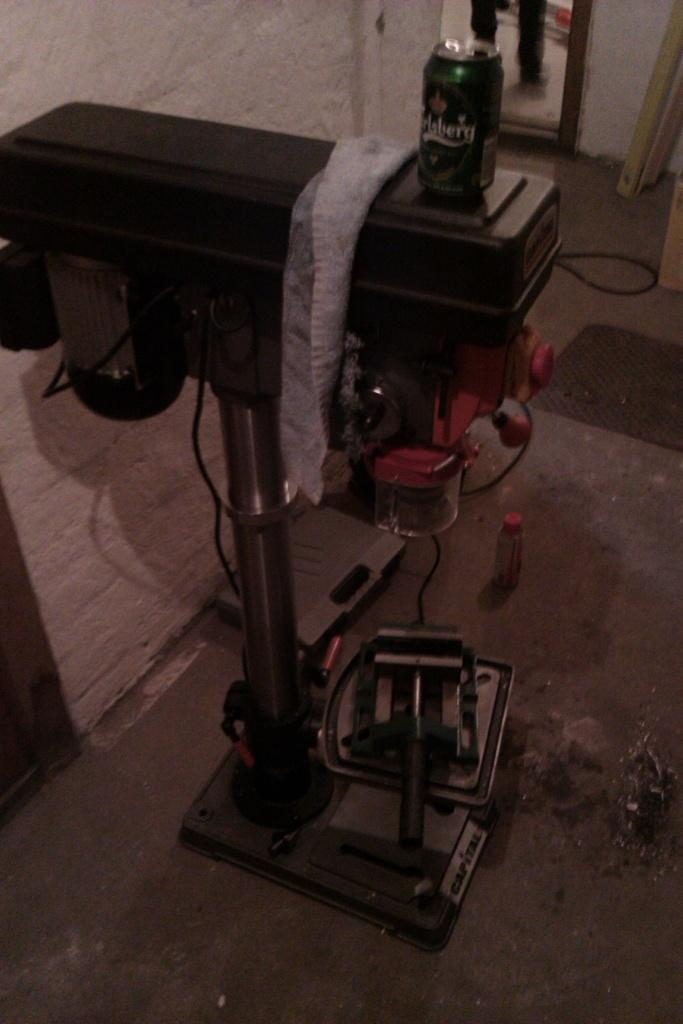<image>
Provide a brief description of the given image. A green can of Carlsberg beer stands on a platform. 